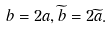Convert formula to latex. <formula><loc_0><loc_0><loc_500><loc_500>b = 2 a , \widetilde { b } = 2 \widetilde { a } .</formula> 